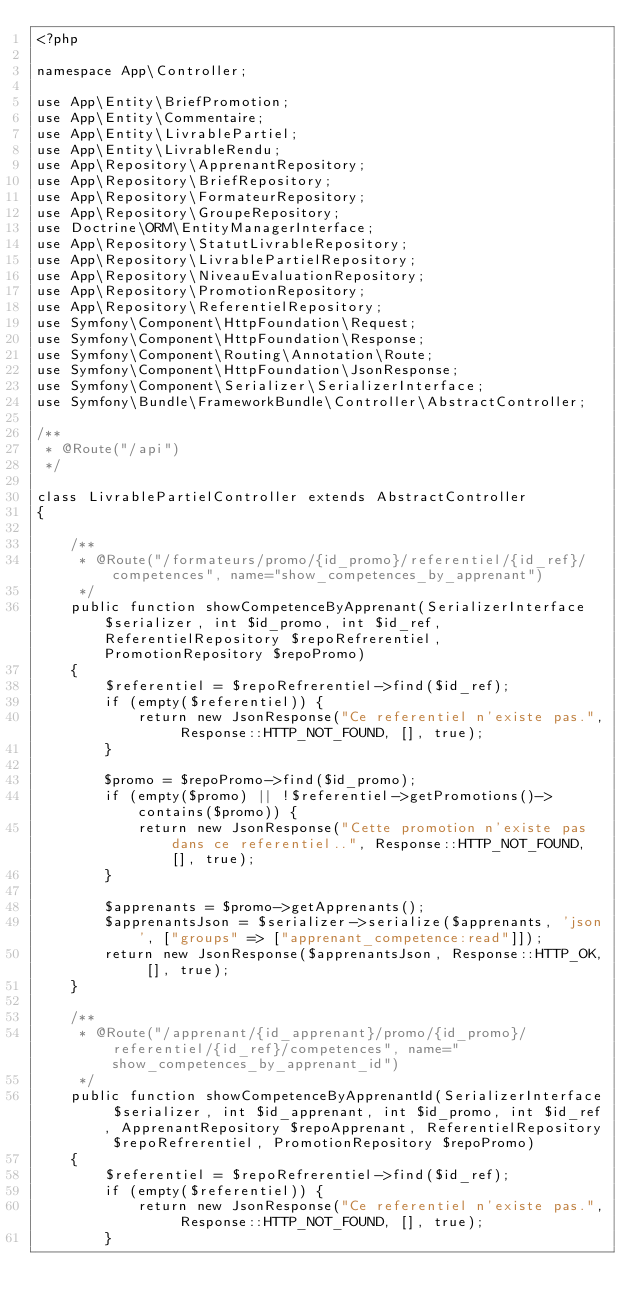<code> <loc_0><loc_0><loc_500><loc_500><_PHP_><?php

namespace App\Controller;

use App\Entity\BriefPromotion;
use App\Entity\Commentaire;
use App\Entity\LivrablePartiel;
use App\Entity\LivrableRendu;
use App\Repository\ApprenantRepository;
use App\Repository\BriefRepository;
use App\Repository\FormateurRepository;
use App\Repository\GroupeRepository;
use Doctrine\ORM\EntityManagerInterface;
use App\Repository\StatutLivrableRepository;
use App\Repository\LivrablePartielRepository;
use App\Repository\NiveauEvaluationRepository;
use App\Repository\PromotionRepository;
use App\Repository\ReferentielRepository;
use Symfony\Component\HttpFoundation\Request;
use Symfony\Component\HttpFoundation\Response;
use Symfony\Component\Routing\Annotation\Route;
use Symfony\Component\HttpFoundation\JsonResponse;
use Symfony\Component\Serializer\SerializerInterface;
use Symfony\Bundle\FrameworkBundle\Controller\AbstractController;

/**
 * @Route("/api")
 */

class LivrablePartielController extends AbstractController
{

    /**
     * @Route("/formateurs/promo/{id_promo}/referentiel/{id_ref}/competences", name="show_competences_by_apprenant")
     */
    public function showCompetenceByApprenant(SerializerInterface $serializer, int $id_promo, int $id_ref, ReferentielRepository $repoRefrerentiel, PromotionRepository $repoPromo)
    {
        $referentiel = $repoRefrerentiel->find($id_ref);
        if (empty($referentiel)) {
            return new JsonResponse("Ce referentiel n'existe pas.", Response::HTTP_NOT_FOUND, [], true);
        }

        $promo = $repoPromo->find($id_promo);
        if (empty($promo) || !$referentiel->getPromotions()->contains($promo)) {
            return new JsonResponse("Cette promotion n'existe pas dans ce referentiel..", Response::HTTP_NOT_FOUND, [], true);
        }

        $apprenants = $promo->getApprenants();
        $apprenantsJson = $serializer->serialize($apprenants, 'json', ["groups" => ["apprenant_competence:read"]]);
        return new JsonResponse($apprenantsJson, Response::HTTP_OK, [], true);
    }

    /**
     * @Route("/apprenant/{id_apprenant}/promo/{id_promo}/referentiel/{id_ref}/competences", name="show_competences_by_apprenant_id")
     */
    public function showCompetenceByApprenantId(SerializerInterface $serializer, int $id_apprenant, int $id_promo, int $id_ref, ApprenantRepository $repoApprenant, ReferentielRepository $repoRefrerentiel, PromotionRepository $repoPromo)
    {
        $referentiel = $repoRefrerentiel->find($id_ref);
        if (empty($referentiel)) {
            return new JsonResponse("Ce referentiel n'existe pas.", Response::HTTP_NOT_FOUND, [], true);
        }
</code> 